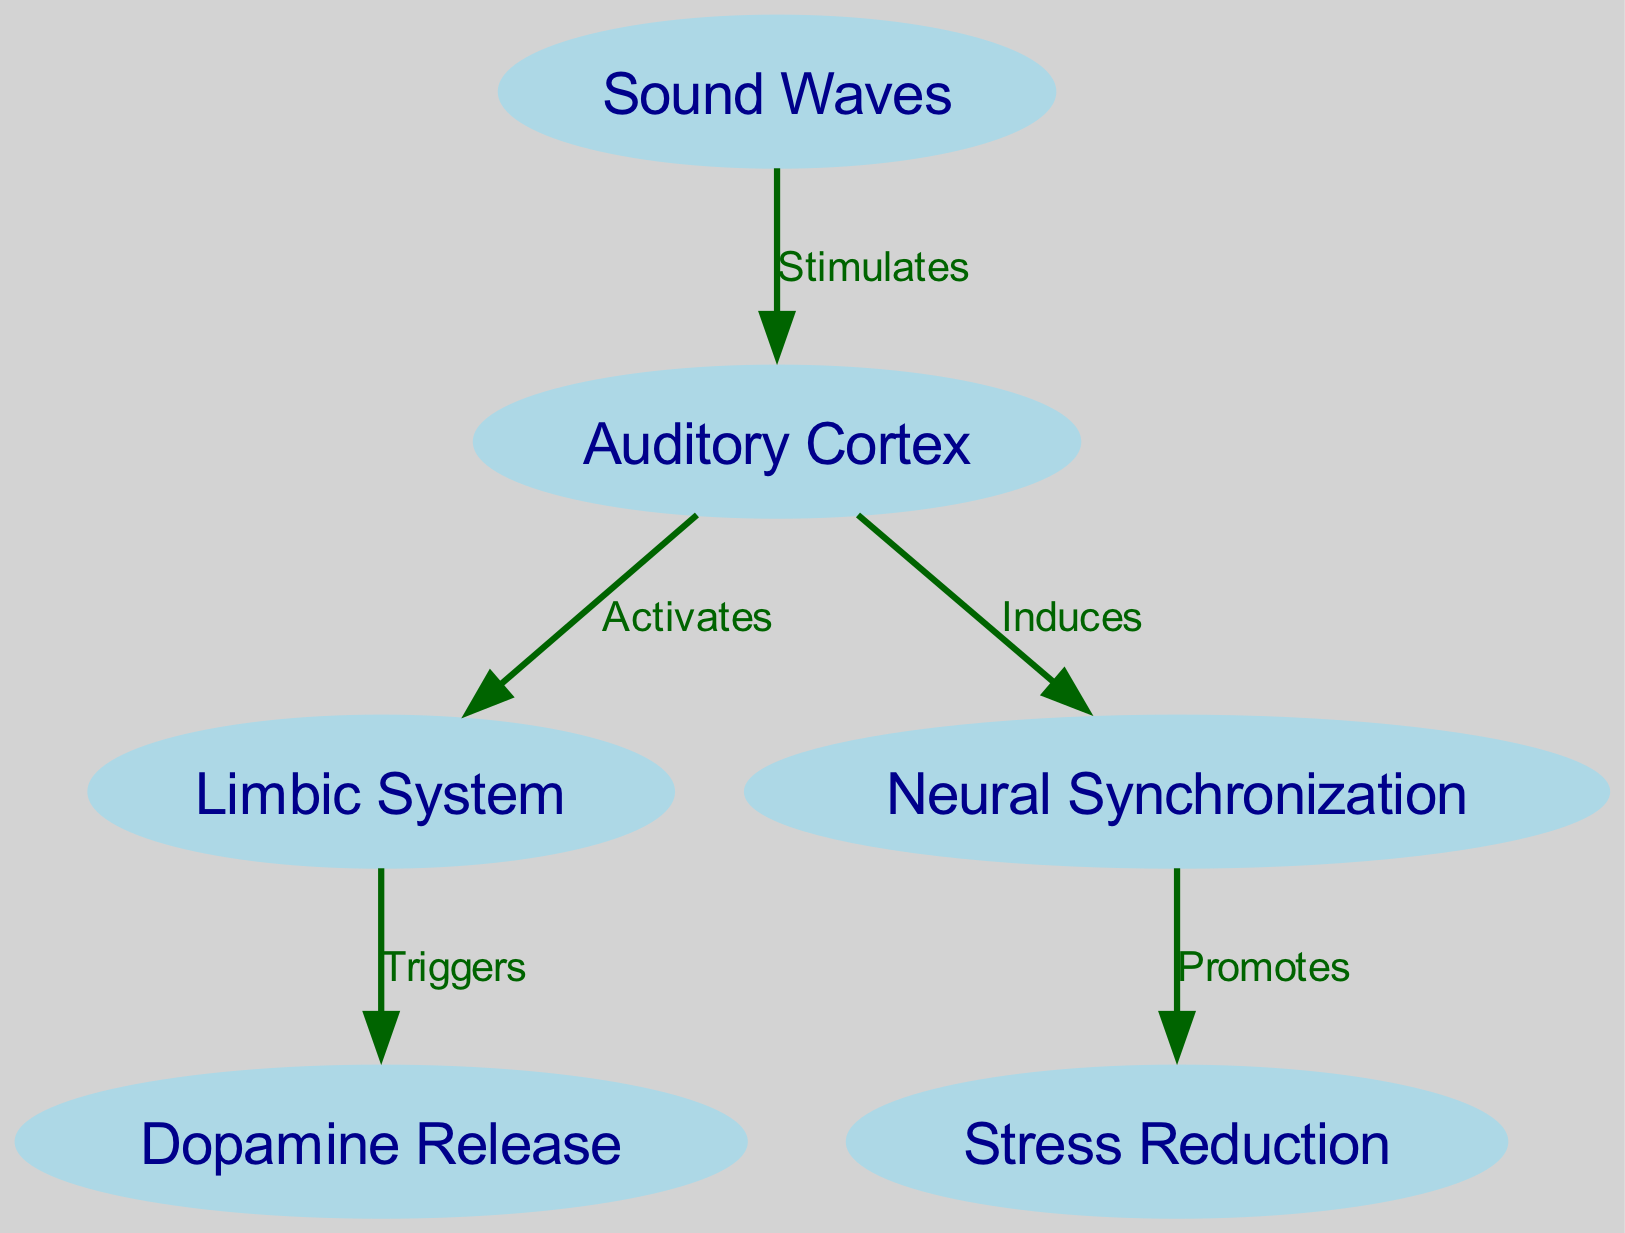What are the main nodes represented in the diagram? The main nodes in the diagram are identified as "Sound Waves," "Auditory Cortex," "Limbic System," "Neural Synchronization," "Dopamine Release," and "Stress Reduction." By counting the nodes listed in the data, I identified a total of six distinct nodes.
Answer: Sound Waves, Auditory Cortex, Limbic System, Neural Synchronization, Dopamine Release, Stress Reduction How many edges are there in the diagram? The diagram contains edges that define the relationships between the nodes. Upon reviewing the data, there are five edges listed connecting the nodes.
Answer: 5 What does "Sound Waves" stimulate? The diagram indicates that "Sound Waves" stimulates the "Auditory Cortex." By tracing the edge from "Sound Waves" to "Auditory Cortex," I confirm this activation.
Answer: Auditory Cortex What does "Auditory Cortex" activate? According to the diagram, the "Auditory Cortex" activates the "Limbic System." By following the directed edge from "Auditory Cortex" to "Limbic System," this relationship is affirmed.
Answer: Limbic System Which node promotes stress reduction? The "Neural Synchronization" node promotes stress reduction as indicated in the diagram through the edge leading from "Neural Synchronization" to "Stress Reduction." This confirms the direct relationship illustrated.
Answer: Stress Reduction What action triggers dopamine release? The diagram shows that the "Limbic System" triggers dopamine release. By inspecting the edge from "Limbic System" to "Dopamine Release," this causal relationship is evident.
Answer: Triggers What is the flow of influence starting from "Sound Waves" to "Stress Reduction"? To trace the influence, I start from "Sound Waves," which stimulates the "Auditory Cortex." This cortex then activates the "Limbic System." The limbic system triggers dopamine release and promotes neural synchronization, which ultimately leads to stress reduction. This sequence follows the directed edges depicted in the diagram.
Answer: Sound Waves → Auditory Cortex → Limbic System → Dopamine Release → Neural Synchronization → Stress Reduction 